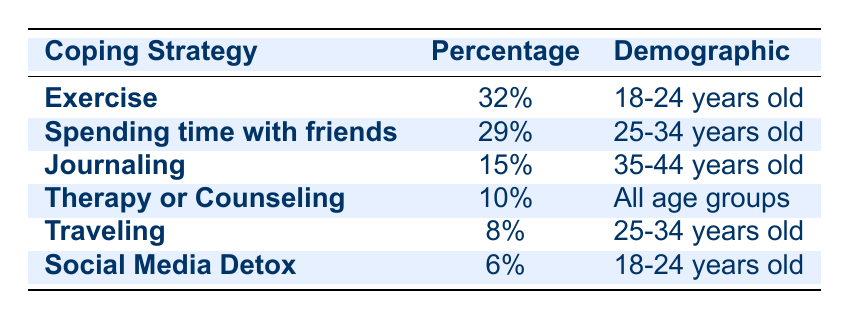What is the coping strategy with the highest percentage among young adults aged 18-24? According to the table, the coping strategy listed for the demographic of 18-24 years old is "Exercise" with a percentage of 32%, which is the highest among this group compared to "Social Media Detox" at 6%.
Answer: Exercise How many coping strategies are listed for the demographic of 25-34 years old? The table includes two coping strategies for the demographic of 25-34 years old: "Spending time with friends" and "Traveling". Thus, the count is 2.
Answer: 2 What is the percentage of individuals who engage in journaling? The data shows that "Journaling" has a percentage of 15%. Thus, the percentage of individuals who engage in journaling is 15%.
Answer: 15% Is "Therapy or Counseling" considered a popular coping strategy compared to others? "Therapy or Counseling" has a percentage of 10%, which is lower than other strategies like "Exercise" at 32% and "Spending time with friends" at 29%. Therefore, it is not considered popular compared to these other options.
Answer: No What is the total percentage of coping strategies listed for individuals aged 18-24? The total percentage for 18-24 years old includes "Exercise" at 32% and "Social Media Detox" at 6%. Adding them together gives: 32 + 6 = 38%. Therefore, the total is 38%.
Answer: 38% Which coping strategy is least employed according to the survey results? The coping strategy with the least percentage is "Social Media Detox," which has a percentage of 6%. Therefore, it is the least employed strategy in the survey results.
Answer: Social Media Detox What is the difference in percentage between the most and least popular coping strategies listed? "Exercise" is the most popular with 32%, and "Social Media Detox" is the least with 6%. The difference is calculated as: 32 - 6 = 26%. Thus, the difference is 26%.
Answer: 26% Does the table show any coping strategy that is recommended for all age groups? Yes, "Therapy or Counseling" is recommended for all age groups, as it explicitly states that it applies to "All age groups" in the demographic column.
Answer: Yes 